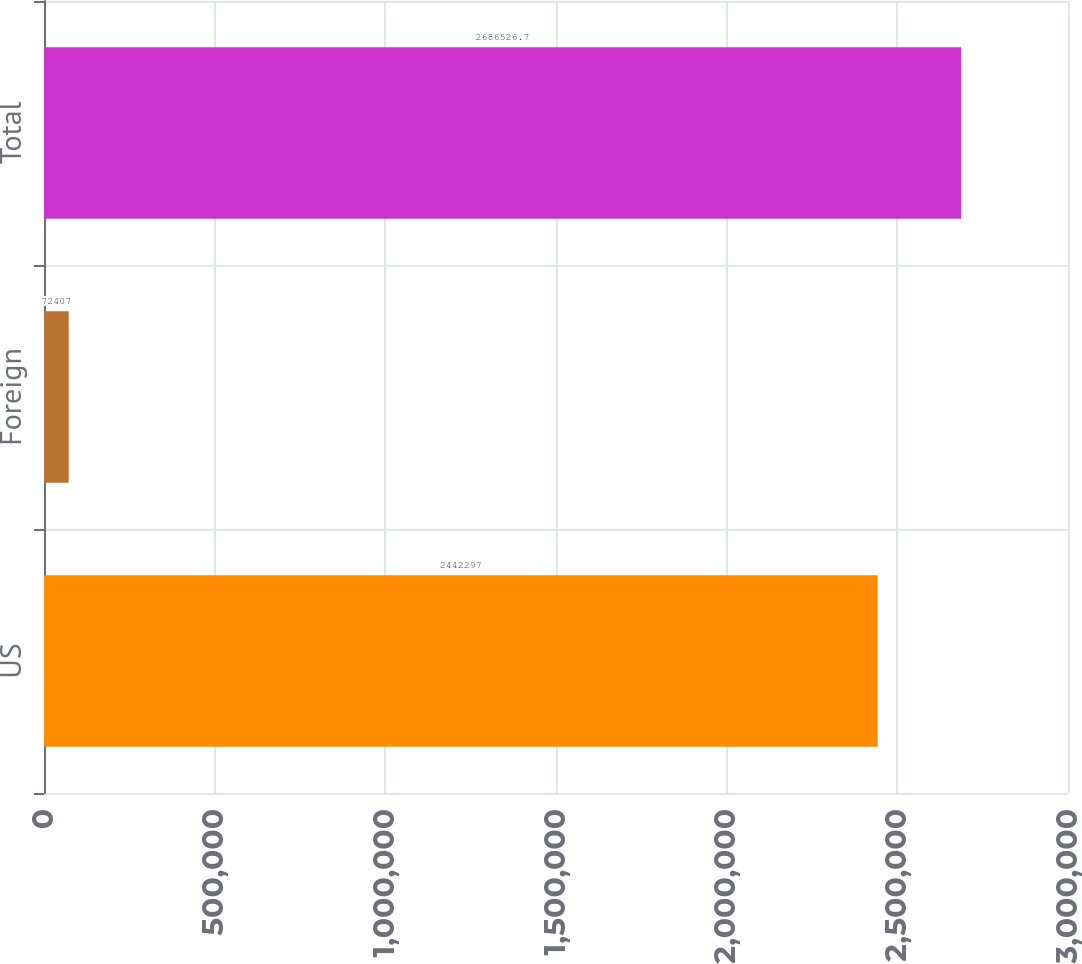Convert chart to OTSL. <chart><loc_0><loc_0><loc_500><loc_500><bar_chart><fcel>US<fcel>Foreign<fcel>Total<nl><fcel>2.4423e+06<fcel>72407<fcel>2.68653e+06<nl></chart> 